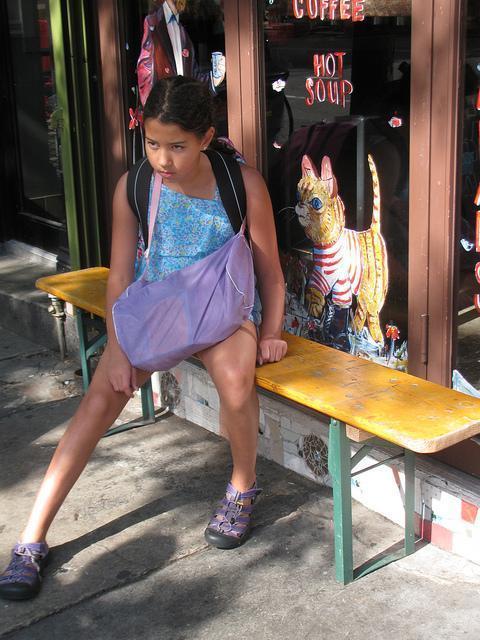How many people are sitting?
Give a very brief answer. 1. 